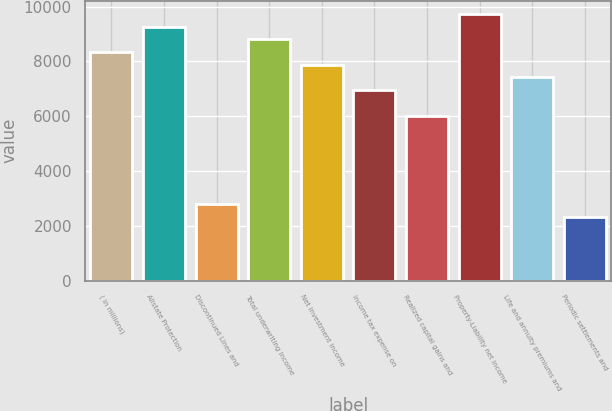Convert chart. <chart><loc_0><loc_0><loc_500><loc_500><bar_chart><fcel>( in millions)<fcel>Allstate Protection<fcel>Discontinued Lines and<fcel>Total underwriting income<fcel>Net investment income<fcel>Income tax expense on<fcel>Realized capital gains and<fcel>Property-Liability net income<fcel>Life and annuity premiums and<fcel>Periodic settlements and<nl><fcel>8343.2<fcel>9270<fcel>2782.4<fcel>8806.6<fcel>7879.8<fcel>6953<fcel>6026.2<fcel>9733.4<fcel>7416.4<fcel>2319<nl></chart> 